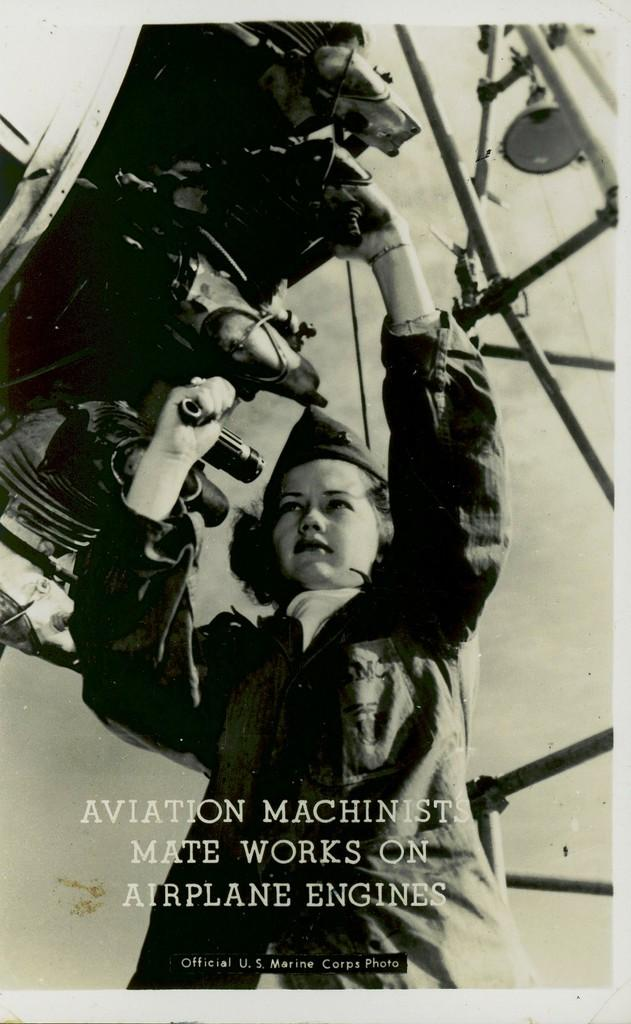What is the main subject of the image? The main subject of the image is a woman. What is the woman doing in the image? The woman is standing in the image. What is the woman holding in her hands? The woman is holding something in her hands, but the specific object is not mentioned in the facts. What type of country is depicted in the background of the image? There is no country depicted in the image; it only features a woman standing and holding something in her hands. What color is the button on the woman's veil in the image? There is no veil or button present in the image. 